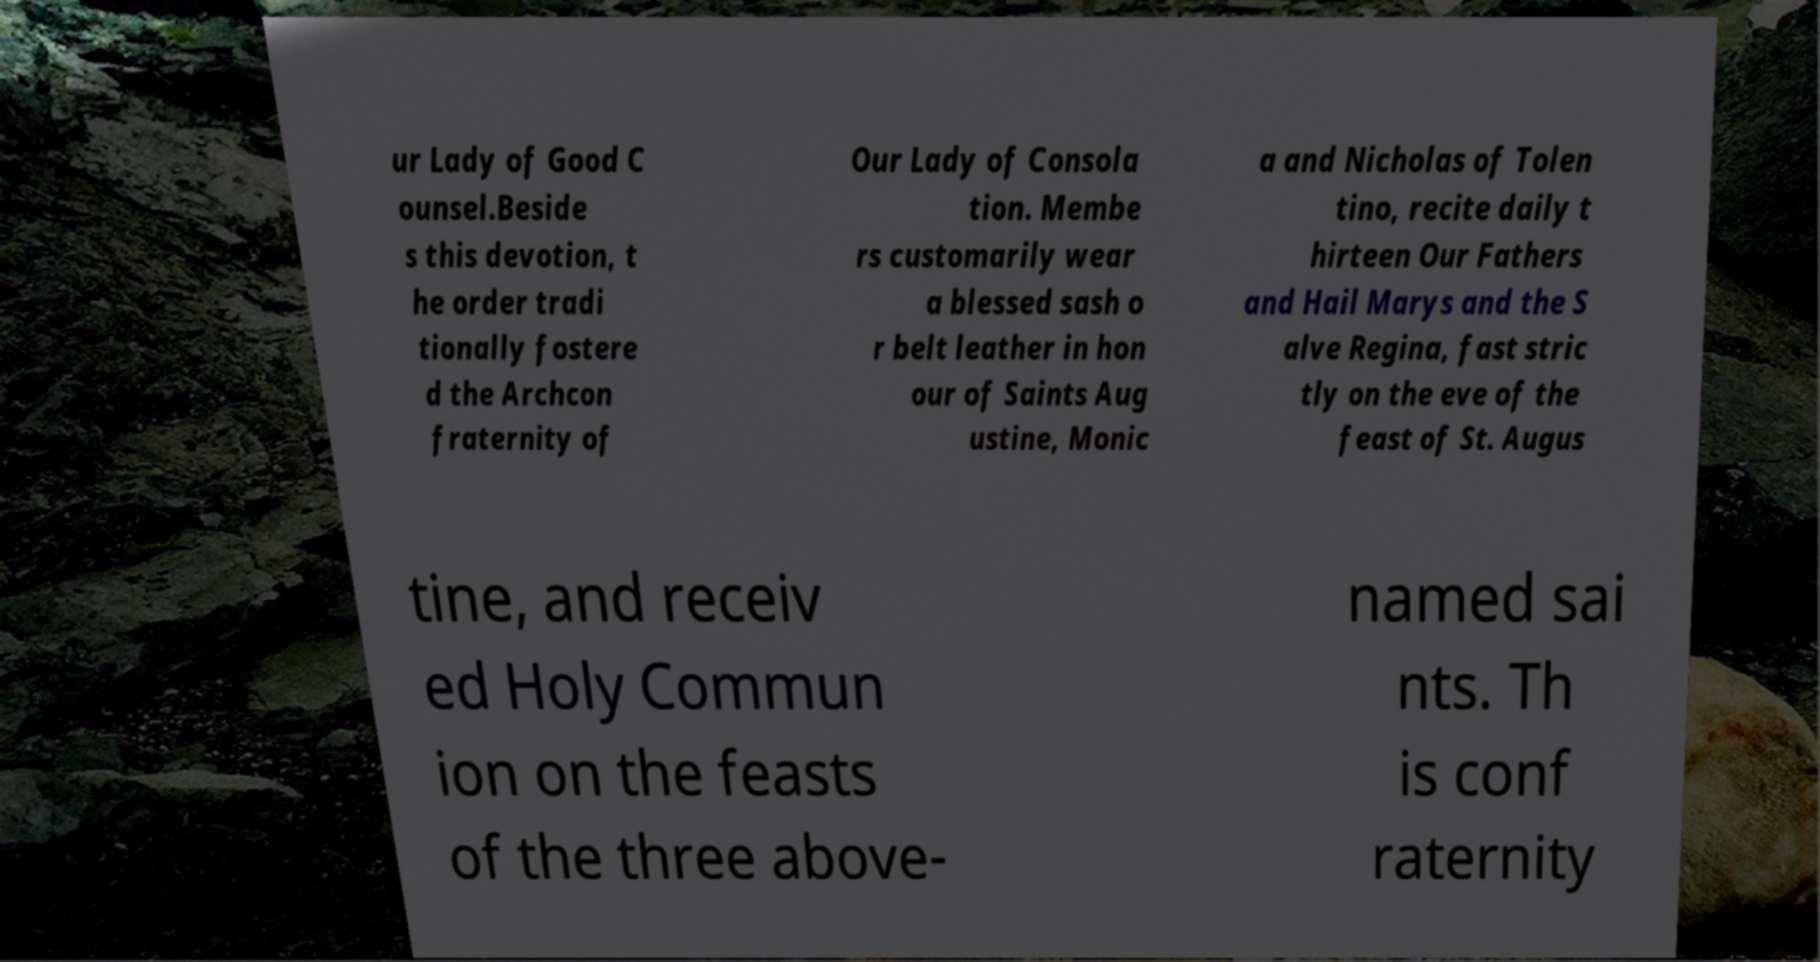Can you accurately transcribe the text from the provided image for me? ur Lady of Good C ounsel.Beside s this devotion, t he order tradi tionally fostere d the Archcon fraternity of Our Lady of Consola tion. Membe rs customarily wear a blessed sash o r belt leather in hon our of Saints Aug ustine, Monic a and Nicholas of Tolen tino, recite daily t hirteen Our Fathers and Hail Marys and the S alve Regina, fast stric tly on the eve of the feast of St. Augus tine, and receiv ed Holy Commun ion on the feasts of the three above- named sai nts. Th is conf raternity 